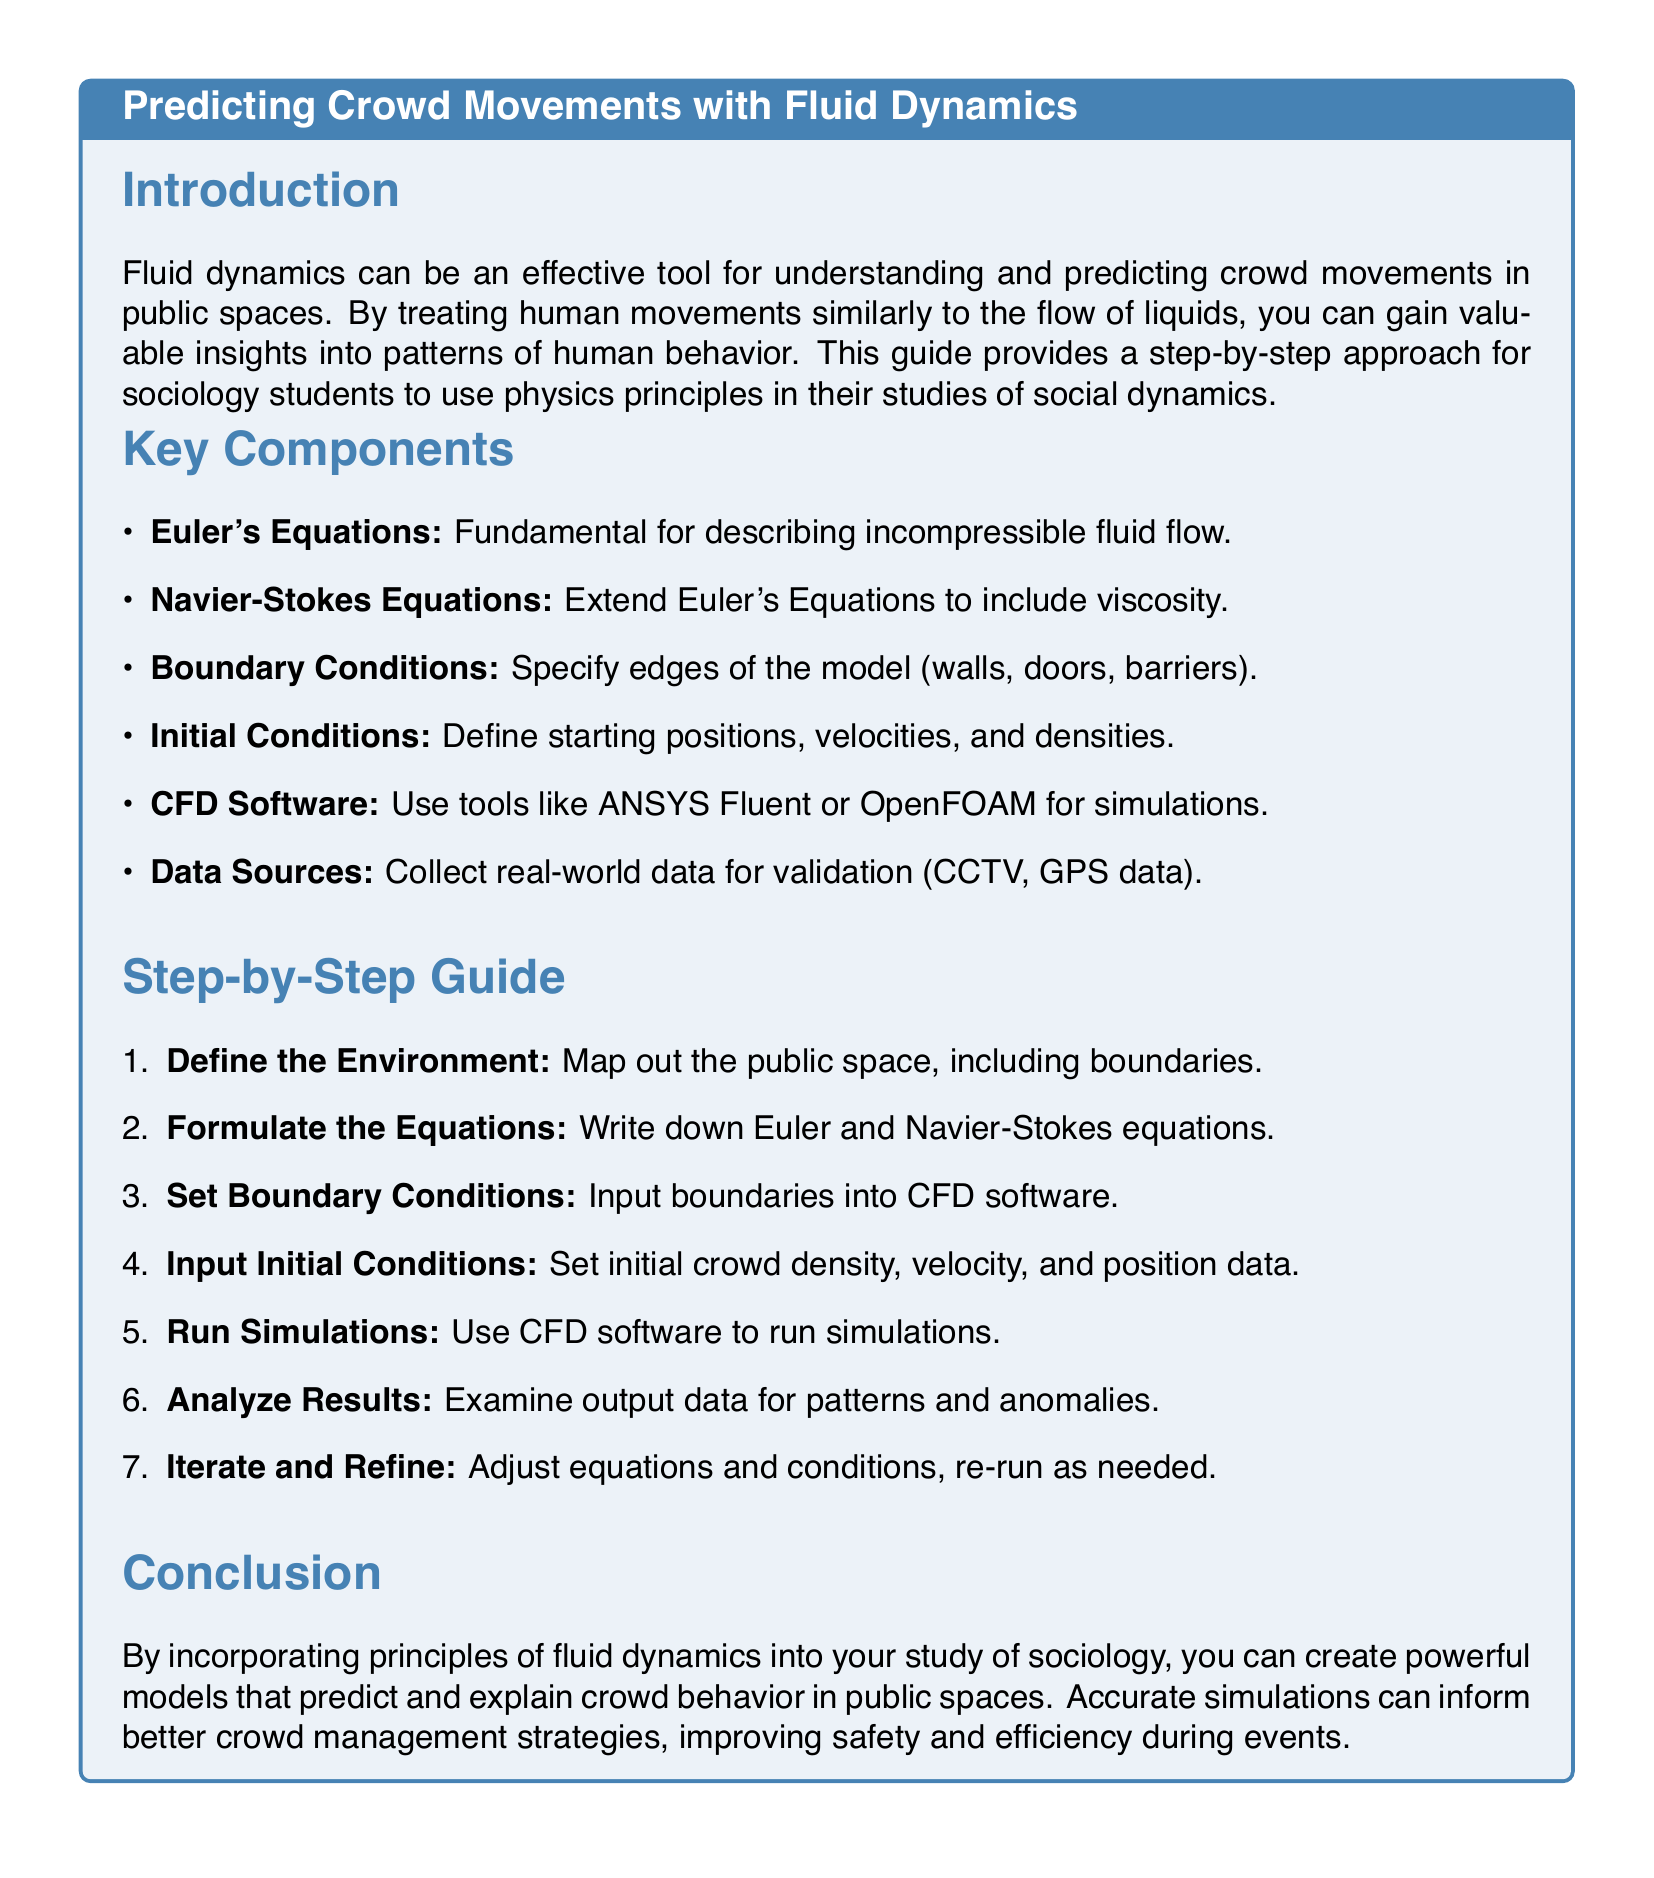What is the title of the document? The title appears at the top of the document and gives the main topic covered, which is predicting crowd movements with fluid dynamics.
Answer: Predicting Crowd Movements with Fluid Dynamics What is the first step in the guide? The first step is listed in the step-by-step guide and involves mapping out the environment.
Answer: Define the Environment Which equations are fundamental for describing incompressible fluid flow? The document states that Euler's Equations are fundamental for this purpose.
Answer: Euler's Equations What software is recommended for running simulations? The document mentions CFD software options, specifically providing examples of tools that can be used.
Answer: ANSYS Fluent or OpenFOAM What is the main outcome of applying fluid dynamics principles in sociology? The conclusion highlights the purpose of using these principles, which is to predict crowd behavior effectively.
Answer: Predict and explain crowd behavior How many key components are listed in the document? By counting the items in the Key Components section, we can determine the total number of components.
Answer: Six What color is used for the title text in the sections? The title text color is specifically defined in the document through its styling and highlights.
Answer: Sociology blue What type of data sources are suggested for validation? The document suggests real-world data sources that can help validate the models being created.
Answer: CCTV, GPS data 